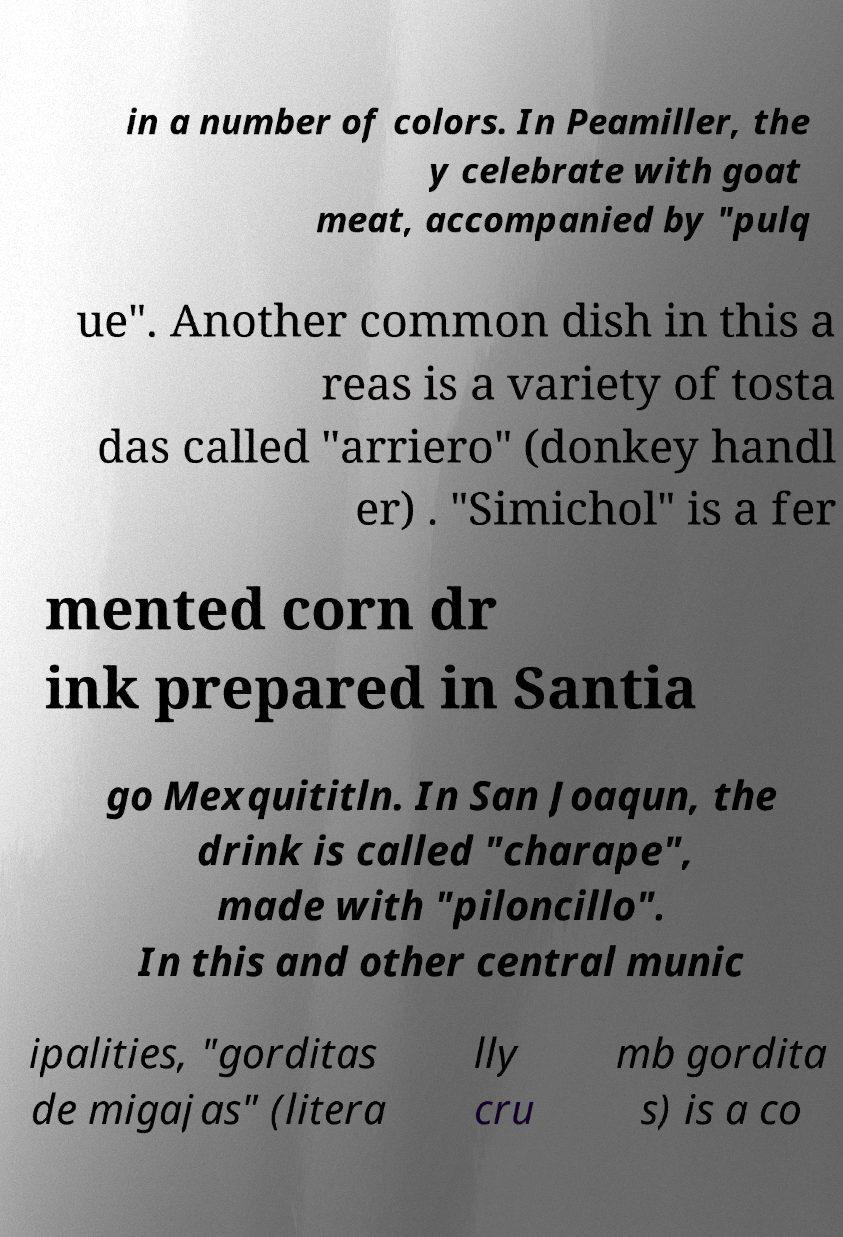Could you assist in decoding the text presented in this image and type it out clearly? in a number of colors. In Peamiller, the y celebrate with goat meat, accompanied by "pulq ue". Another common dish in this a reas is a variety of tosta das called "arriero" (donkey handl er) . "Simichol" is a fer mented corn dr ink prepared in Santia go Mexquititln. In San Joaqun, the drink is called "charape", made with "piloncillo". In this and other central munic ipalities, "gorditas de migajas" (litera lly cru mb gordita s) is a co 